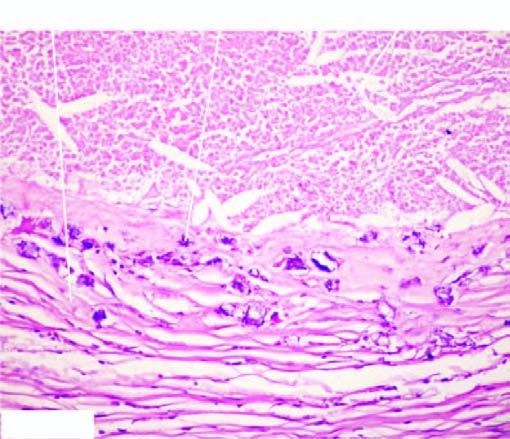what does the periphery show?
Answer the question using a single word or phrase. Healed granulomas 